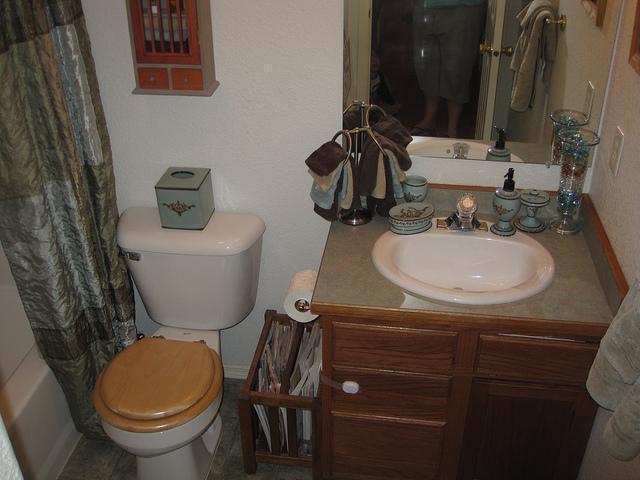What color is the tissue box on the top of the toilet bowl?
From the following four choices, select the correct answer to address the question.
Options: Red, purple, blue, yellow. Blue. What is the box on the toilet tank used for?
Indicate the correct response by choosing from the four available options to answer the question.
Options: Shampoo storage, soap, cotton balls, tissue boxes. Tissue boxes. 